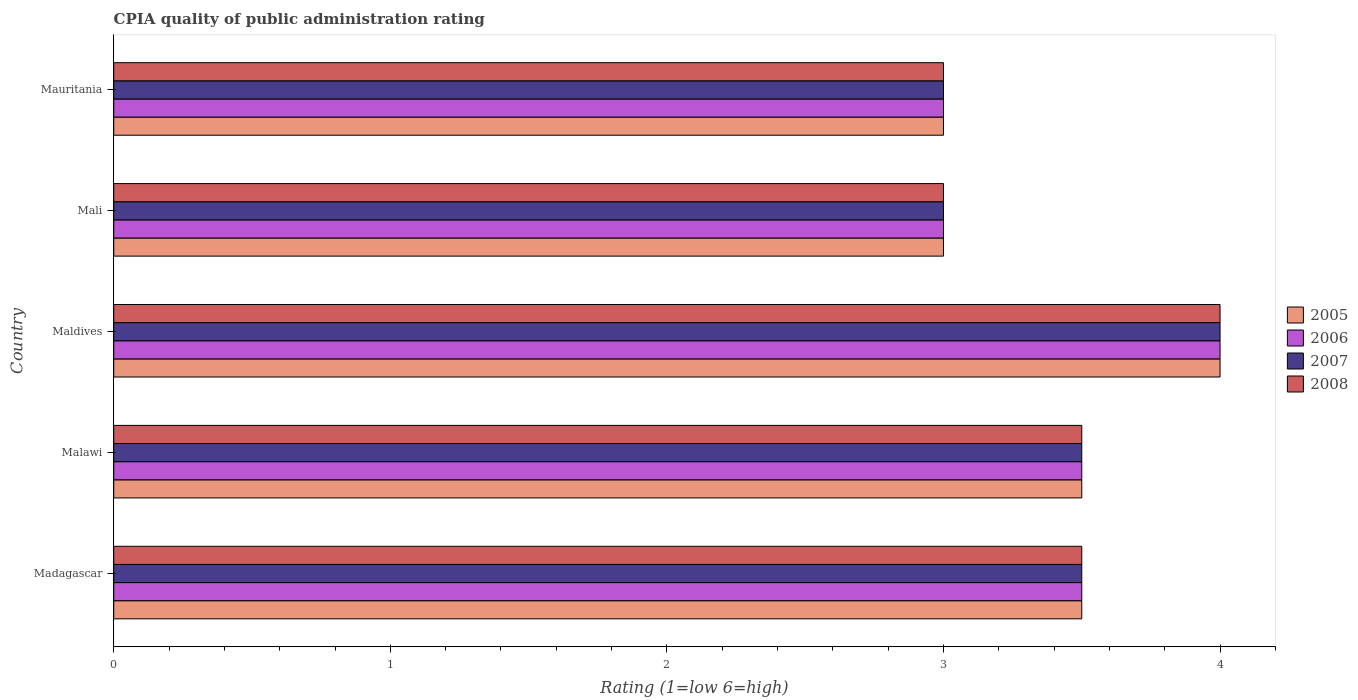How many different coloured bars are there?
Offer a very short reply. 4. How many groups of bars are there?
Give a very brief answer. 5. Are the number of bars per tick equal to the number of legend labels?
Your answer should be compact. Yes. How many bars are there on the 1st tick from the top?
Give a very brief answer. 4. How many bars are there on the 3rd tick from the bottom?
Offer a very short reply. 4. What is the label of the 2nd group of bars from the top?
Offer a terse response. Mali. In how many cases, is the number of bars for a given country not equal to the number of legend labels?
Keep it short and to the point. 0. Across all countries, what is the minimum CPIA rating in 2007?
Provide a short and direct response. 3. In which country was the CPIA rating in 2005 maximum?
Provide a succinct answer. Maldives. In which country was the CPIA rating in 2008 minimum?
Offer a very short reply. Mali. What is the average CPIA rating in 2007 per country?
Provide a short and direct response. 3.4. What is the difference between the CPIA rating in 2006 and CPIA rating in 2008 in Mali?
Provide a succinct answer. 0. In how many countries, is the CPIA rating in 2005 greater than 0.2 ?
Your answer should be compact. 5. What is the ratio of the CPIA rating in 2005 in Madagascar to that in Mauritania?
Keep it short and to the point. 1.17. What does the 4th bar from the bottom in Madagascar represents?
Ensure brevity in your answer.  2008. How many bars are there?
Your answer should be very brief. 20. How many countries are there in the graph?
Make the answer very short. 5. Where does the legend appear in the graph?
Provide a short and direct response. Center right. How are the legend labels stacked?
Provide a short and direct response. Vertical. What is the title of the graph?
Give a very brief answer. CPIA quality of public administration rating. What is the Rating (1=low 6=high) in 2006 in Madagascar?
Keep it short and to the point. 3.5. What is the Rating (1=low 6=high) in 2008 in Malawi?
Your response must be concise. 3.5. What is the Rating (1=low 6=high) of 2005 in Maldives?
Your answer should be very brief. 4. What is the Rating (1=low 6=high) in 2007 in Maldives?
Give a very brief answer. 4. What is the Rating (1=low 6=high) of 2005 in Mali?
Your answer should be very brief. 3. What is the Rating (1=low 6=high) of 2007 in Mali?
Offer a terse response. 3. What is the Rating (1=low 6=high) of 2005 in Mauritania?
Keep it short and to the point. 3. What is the Rating (1=low 6=high) in 2006 in Mauritania?
Your answer should be compact. 3. What is the Rating (1=low 6=high) of 2007 in Mauritania?
Your response must be concise. 3. Across all countries, what is the maximum Rating (1=low 6=high) in 2005?
Your answer should be very brief. 4. Across all countries, what is the minimum Rating (1=low 6=high) in 2005?
Your response must be concise. 3. Across all countries, what is the minimum Rating (1=low 6=high) in 2007?
Provide a succinct answer. 3. Across all countries, what is the minimum Rating (1=low 6=high) of 2008?
Your answer should be compact. 3. What is the total Rating (1=low 6=high) in 2007 in the graph?
Provide a succinct answer. 17. What is the total Rating (1=low 6=high) of 2008 in the graph?
Keep it short and to the point. 17. What is the difference between the Rating (1=low 6=high) in 2007 in Madagascar and that in Malawi?
Your answer should be compact. 0. What is the difference between the Rating (1=low 6=high) in 2008 in Madagascar and that in Malawi?
Provide a short and direct response. 0. What is the difference between the Rating (1=low 6=high) in 2005 in Madagascar and that in Maldives?
Ensure brevity in your answer.  -0.5. What is the difference between the Rating (1=low 6=high) in 2007 in Madagascar and that in Maldives?
Your answer should be very brief. -0.5. What is the difference between the Rating (1=low 6=high) of 2008 in Madagascar and that in Mali?
Your response must be concise. 0.5. What is the difference between the Rating (1=low 6=high) of 2005 in Madagascar and that in Mauritania?
Your answer should be very brief. 0.5. What is the difference between the Rating (1=low 6=high) in 2006 in Madagascar and that in Mauritania?
Your response must be concise. 0.5. What is the difference between the Rating (1=low 6=high) of 2007 in Madagascar and that in Mauritania?
Provide a short and direct response. 0.5. What is the difference between the Rating (1=low 6=high) of 2006 in Malawi and that in Maldives?
Offer a terse response. -0.5. What is the difference between the Rating (1=low 6=high) in 2007 in Malawi and that in Maldives?
Ensure brevity in your answer.  -0.5. What is the difference between the Rating (1=low 6=high) in 2006 in Malawi and that in Mali?
Provide a short and direct response. 0.5. What is the difference between the Rating (1=low 6=high) in 2007 in Malawi and that in Mali?
Your response must be concise. 0.5. What is the difference between the Rating (1=low 6=high) in 2005 in Malawi and that in Mauritania?
Your answer should be very brief. 0.5. What is the difference between the Rating (1=low 6=high) of 2006 in Malawi and that in Mauritania?
Your response must be concise. 0.5. What is the difference between the Rating (1=low 6=high) in 2007 in Malawi and that in Mauritania?
Provide a short and direct response. 0.5. What is the difference between the Rating (1=low 6=high) of 2005 in Maldives and that in Mali?
Your answer should be very brief. 1. What is the difference between the Rating (1=low 6=high) of 2007 in Maldives and that in Mali?
Your answer should be very brief. 1. What is the difference between the Rating (1=low 6=high) in 2008 in Maldives and that in Mali?
Your response must be concise. 1. What is the difference between the Rating (1=low 6=high) of 2005 in Maldives and that in Mauritania?
Give a very brief answer. 1. What is the difference between the Rating (1=low 6=high) of 2007 in Maldives and that in Mauritania?
Provide a short and direct response. 1. What is the difference between the Rating (1=low 6=high) of 2008 in Maldives and that in Mauritania?
Your answer should be compact. 1. What is the difference between the Rating (1=low 6=high) of 2007 in Mali and that in Mauritania?
Provide a short and direct response. 0. What is the difference between the Rating (1=low 6=high) in 2006 in Madagascar and the Rating (1=low 6=high) in 2007 in Malawi?
Provide a short and direct response. 0. What is the difference between the Rating (1=low 6=high) of 2006 in Madagascar and the Rating (1=low 6=high) of 2008 in Malawi?
Your answer should be compact. 0. What is the difference between the Rating (1=low 6=high) in 2007 in Madagascar and the Rating (1=low 6=high) in 2008 in Malawi?
Ensure brevity in your answer.  0. What is the difference between the Rating (1=low 6=high) in 2005 in Madagascar and the Rating (1=low 6=high) in 2007 in Maldives?
Make the answer very short. -0.5. What is the difference between the Rating (1=low 6=high) in 2005 in Madagascar and the Rating (1=low 6=high) in 2008 in Maldives?
Your response must be concise. -0.5. What is the difference between the Rating (1=low 6=high) in 2006 in Madagascar and the Rating (1=low 6=high) in 2007 in Maldives?
Provide a short and direct response. -0.5. What is the difference between the Rating (1=low 6=high) in 2006 in Madagascar and the Rating (1=low 6=high) in 2007 in Mali?
Give a very brief answer. 0.5. What is the difference between the Rating (1=low 6=high) of 2006 in Madagascar and the Rating (1=low 6=high) of 2008 in Mali?
Give a very brief answer. 0.5. What is the difference between the Rating (1=low 6=high) of 2007 in Madagascar and the Rating (1=low 6=high) of 2008 in Mali?
Your answer should be very brief. 0.5. What is the difference between the Rating (1=low 6=high) of 2005 in Madagascar and the Rating (1=low 6=high) of 2006 in Mauritania?
Provide a succinct answer. 0.5. What is the difference between the Rating (1=low 6=high) of 2006 in Madagascar and the Rating (1=low 6=high) of 2007 in Mauritania?
Offer a very short reply. 0.5. What is the difference between the Rating (1=low 6=high) of 2005 in Malawi and the Rating (1=low 6=high) of 2007 in Maldives?
Ensure brevity in your answer.  -0.5. What is the difference between the Rating (1=low 6=high) in 2005 in Malawi and the Rating (1=low 6=high) in 2008 in Maldives?
Your response must be concise. -0.5. What is the difference between the Rating (1=low 6=high) in 2006 in Malawi and the Rating (1=low 6=high) in 2008 in Maldives?
Your answer should be compact. -0.5. What is the difference between the Rating (1=low 6=high) in 2007 in Malawi and the Rating (1=low 6=high) in 2008 in Maldives?
Your answer should be very brief. -0.5. What is the difference between the Rating (1=low 6=high) in 2005 in Malawi and the Rating (1=low 6=high) in 2007 in Mali?
Ensure brevity in your answer.  0.5. What is the difference between the Rating (1=low 6=high) of 2006 in Malawi and the Rating (1=low 6=high) of 2007 in Mali?
Offer a terse response. 0.5. What is the difference between the Rating (1=low 6=high) in 2005 in Malawi and the Rating (1=low 6=high) in 2008 in Mauritania?
Your response must be concise. 0.5. What is the difference between the Rating (1=low 6=high) of 2006 in Malawi and the Rating (1=low 6=high) of 2008 in Mauritania?
Offer a terse response. 0.5. What is the difference between the Rating (1=low 6=high) of 2007 in Malawi and the Rating (1=low 6=high) of 2008 in Mauritania?
Your answer should be very brief. 0.5. What is the difference between the Rating (1=low 6=high) in 2005 in Maldives and the Rating (1=low 6=high) in 2007 in Mali?
Provide a short and direct response. 1. What is the difference between the Rating (1=low 6=high) of 2006 in Maldives and the Rating (1=low 6=high) of 2007 in Mali?
Offer a terse response. 1. What is the difference between the Rating (1=low 6=high) of 2007 in Maldives and the Rating (1=low 6=high) of 2008 in Mali?
Offer a very short reply. 1. What is the difference between the Rating (1=low 6=high) in 2005 in Maldives and the Rating (1=low 6=high) in 2007 in Mauritania?
Provide a succinct answer. 1. What is the difference between the Rating (1=low 6=high) in 2006 in Mali and the Rating (1=low 6=high) in 2007 in Mauritania?
Keep it short and to the point. 0. What is the difference between the Rating (1=low 6=high) in 2006 in Mali and the Rating (1=low 6=high) in 2008 in Mauritania?
Provide a succinct answer. 0. What is the difference between the Rating (1=low 6=high) in 2007 in Mali and the Rating (1=low 6=high) in 2008 in Mauritania?
Provide a short and direct response. 0. What is the average Rating (1=low 6=high) of 2005 per country?
Provide a succinct answer. 3.4. What is the average Rating (1=low 6=high) in 2007 per country?
Give a very brief answer. 3.4. What is the difference between the Rating (1=low 6=high) of 2005 and Rating (1=low 6=high) of 2006 in Madagascar?
Your answer should be compact. 0. What is the difference between the Rating (1=low 6=high) in 2006 and Rating (1=low 6=high) in 2007 in Madagascar?
Offer a terse response. 0. What is the difference between the Rating (1=low 6=high) of 2006 and Rating (1=low 6=high) of 2008 in Madagascar?
Offer a terse response. 0. What is the difference between the Rating (1=low 6=high) of 2007 and Rating (1=low 6=high) of 2008 in Madagascar?
Your answer should be very brief. 0. What is the difference between the Rating (1=low 6=high) of 2006 and Rating (1=low 6=high) of 2007 in Malawi?
Your response must be concise. 0. What is the difference between the Rating (1=low 6=high) of 2005 and Rating (1=low 6=high) of 2006 in Maldives?
Ensure brevity in your answer.  0. What is the difference between the Rating (1=low 6=high) of 2005 and Rating (1=low 6=high) of 2007 in Maldives?
Your answer should be compact. 0. What is the difference between the Rating (1=low 6=high) of 2005 and Rating (1=low 6=high) of 2007 in Mali?
Your response must be concise. 0. What is the difference between the Rating (1=low 6=high) of 2005 and Rating (1=low 6=high) of 2008 in Mali?
Ensure brevity in your answer.  0. What is the difference between the Rating (1=low 6=high) of 2006 and Rating (1=low 6=high) of 2007 in Mali?
Give a very brief answer. 0. What is the difference between the Rating (1=low 6=high) of 2006 and Rating (1=low 6=high) of 2008 in Mali?
Offer a very short reply. 0. What is the difference between the Rating (1=low 6=high) in 2007 and Rating (1=low 6=high) in 2008 in Mali?
Give a very brief answer. 0. What is the difference between the Rating (1=low 6=high) of 2005 and Rating (1=low 6=high) of 2008 in Mauritania?
Ensure brevity in your answer.  0. What is the difference between the Rating (1=low 6=high) of 2006 and Rating (1=low 6=high) of 2007 in Mauritania?
Keep it short and to the point. 0. What is the difference between the Rating (1=low 6=high) of 2006 and Rating (1=low 6=high) of 2008 in Mauritania?
Ensure brevity in your answer.  0. What is the ratio of the Rating (1=low 6=high) of 2005 in Madagascar to that in Malawi?
Your response must be concise. 1. What is the ratio of the Rating (1=low 6=high) of 2007 in Madagascar to that in Malawi?
Give a very brief answer. 1. What is the ratio of the Rating (1=low 6=high) in 2005 in Madagascar to that in Maldives?
Offer a very short reply. 0.88. What is the ratio of the Rating (1=low 6=high) of 2006 in Madagascar to that in Maldives?
Ensure brevity in your answer.  0.88. What is the ratio of the Rating (1=low 6=high) of 2007 in Madagascar to that in Maldives?
Give a very brief answer. 0.88. What is the ratio of the Rating (1=low 6=high) in 2005 in Madagascar to that in Mali?
Offer a very short reply. 1.17. What is the ratio of the Rating (1=low 6=high) of 2006 in Madagascar to that in Mali?
Provide a short and direct response. 1.17. What is the ratio of the Rating (1=low 6=high) in 2005 in Madagascar to that in Mauritania?
Ensure brevity in your answer.  1.17. What is the ratio of the Rating (1=low 6=high) of 2006 in Madagascar to that in Mauritania?
Make the answer very short. 1.17. What is the ratio of the Rating (1=low 6=high) of 2007 in Madagascar to that in Mauritania?
Provide a short and direct response. 1.17. What is the ratio of the Rating (1=low 6=high) of 2006 in Malawi to that in Maldives?
Your answer should be compact. 0.88. What is the ratio of the Rating (1=low 6=high) of 2007 in Malawi to that in Maldives?
Keep it short and to the point. 0.88. What is the ratio of the Rating (1=low 6=high) of 2005 in Malawi to that in Mali?
Offer a very short reply. 1.17. What is the ratio of the Rating (1=low 6=high) of 2008 in Malawi to that in Mali?
Your response must be concise. 1.17. What is the ratio of the Rating (1=low 6=high) in 2007 in Malawi to that in Mauritania?
Give a very brief answer. 1.17. What is the ratio of the Rating (1=low 6=high) in 2007 in Maldives to that in Mali?
Offer a terse response. 1.33. What is the ratio of the Rating (1=low 6=high) in 2006 in Maldives to that in Mauritania?
Your answer should be compact. 1.33. What is the ratio of the Rating (1=low 6=high) in 2008 in Maldives to that in Mauritania?
Give a very brief answer. 1.33. What is the ratio of the Rating (1=low 6=high) in 2006 in Mali to that in Mauritania?
Ensure brevity in your answer.  1. What is the ratio of the Rating (1=low 6=high) in 2008 in Mali to that in Mauritania?
Offer a very short reply. 1. What is the difference between the highest and the second highest Rating (1=low 6=high) in 2005?
Give a very brief answer. 0.5. What is the difference between the highest and the second highest Rating (1=low 6=high) in 2007?
Make the answer very short. 0.5. What is the difference between the highest and the second highest Rating (1=low 6=high) in 2008?
Ensure brevity in your answer.  0.5. What is the difference between the highest and the lowest Rating (1=low 6=high) in 2005?
Offer a very short reply. 1. 